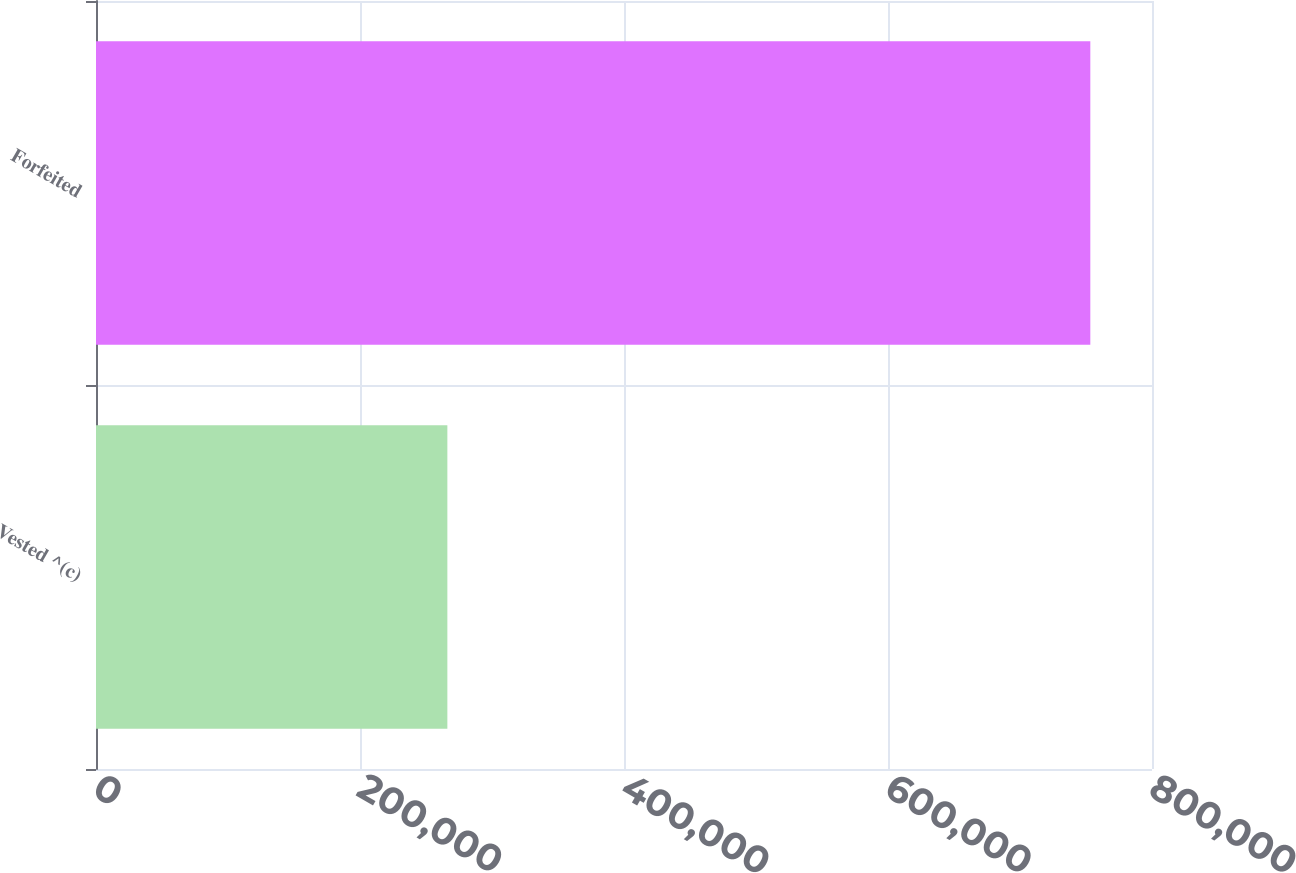Convert chart to OTSL. <chart><loc_0><loc_0><loc_500><loc_500><bar_chart><fcel>Vested ^(c)<fcel>Forfeited<nl><fcel>266184<fcel>753272<nl></chart> 